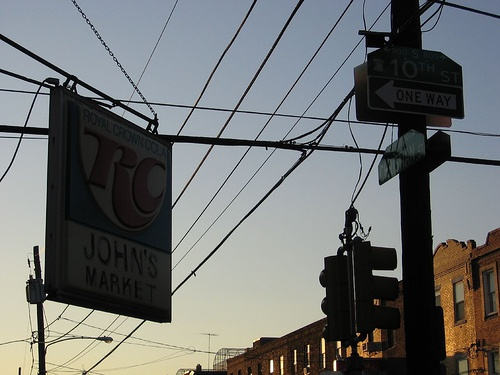Describe the objects in this image and their specific colors. I can see traffic light in darkgray, black, and gray tones, traffic light in darkgray, black, gray, and lightgray tones, and traffic light in darkgray, black, and gray tones in this image. 